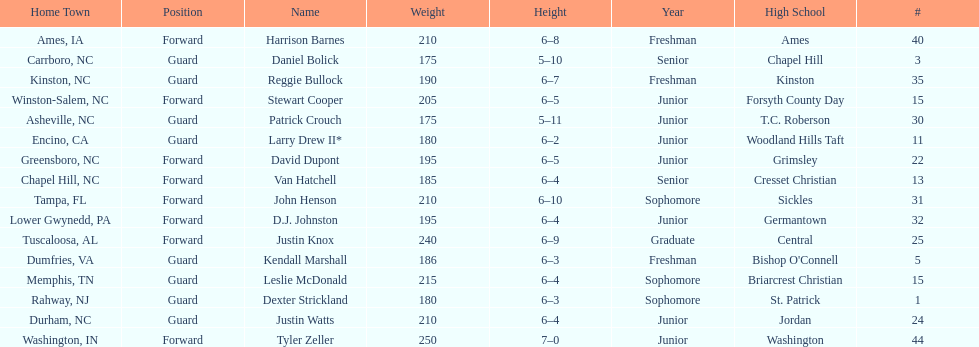What was the number of freshmen on the team? 3. 